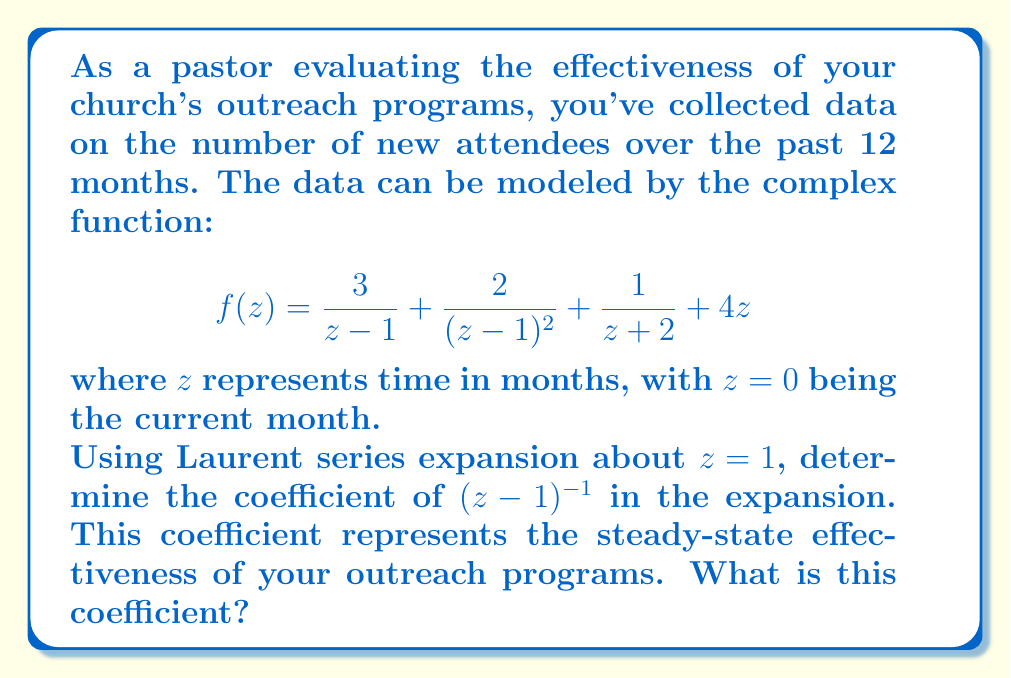Give your solution to this math problem. To solve this problem, we need to find the Laurent series expansion of $f(z)$ about $z=1$ and identify the coefficient of $(z-1)^{-1}$. Let's break it down step-by-step:

1) First, let's separate $f(z)$ into parts:
   $$f(z) = \frac{3}{z-1} + \frac{2}{(z-1)^2} + \frac{1}{z+2} + 4z$$

2) The first two terms are already in the form of a Laurent series about $z=1$:
   $$\frac{3}{z-1} + \frac{2}{(z-1)^2}$$

3) For the third term, $\frac{1}{z+2}$, we need to expand it about $z=1$:
   $$\frac{1}{z+2} = \frac{1}{(z-1)+3} = \frac{1}{3}\cdot\frac{1}{1+\frac{z-1}{3}}$$
   Using the geometric series formula:
   $$\frac{1}{z+2} = \frac{1}{3}\left(1 - \frac{z-1}{3} + \frac{(z-1)^2}{9} - \frac{(z-1)^3}{27} + ...\right)$$

4) For the last term, $4z$, we can rewrite it as:
   $$4z = 4(z-1) + 4$$

5) Combining all terms:
   $$f(z) = \frac{2}{(z-1)^2} + \frac{3}{z-1} + \frac{1}{3} - \frac{1}{9}(z-1) + \frac{1}{27}(z-1)^2 - ... + 4(z-1) + 4$$

6) The coefficient of $(z-1)^{-1}$ in this expansion is 3.
Answer: 3 